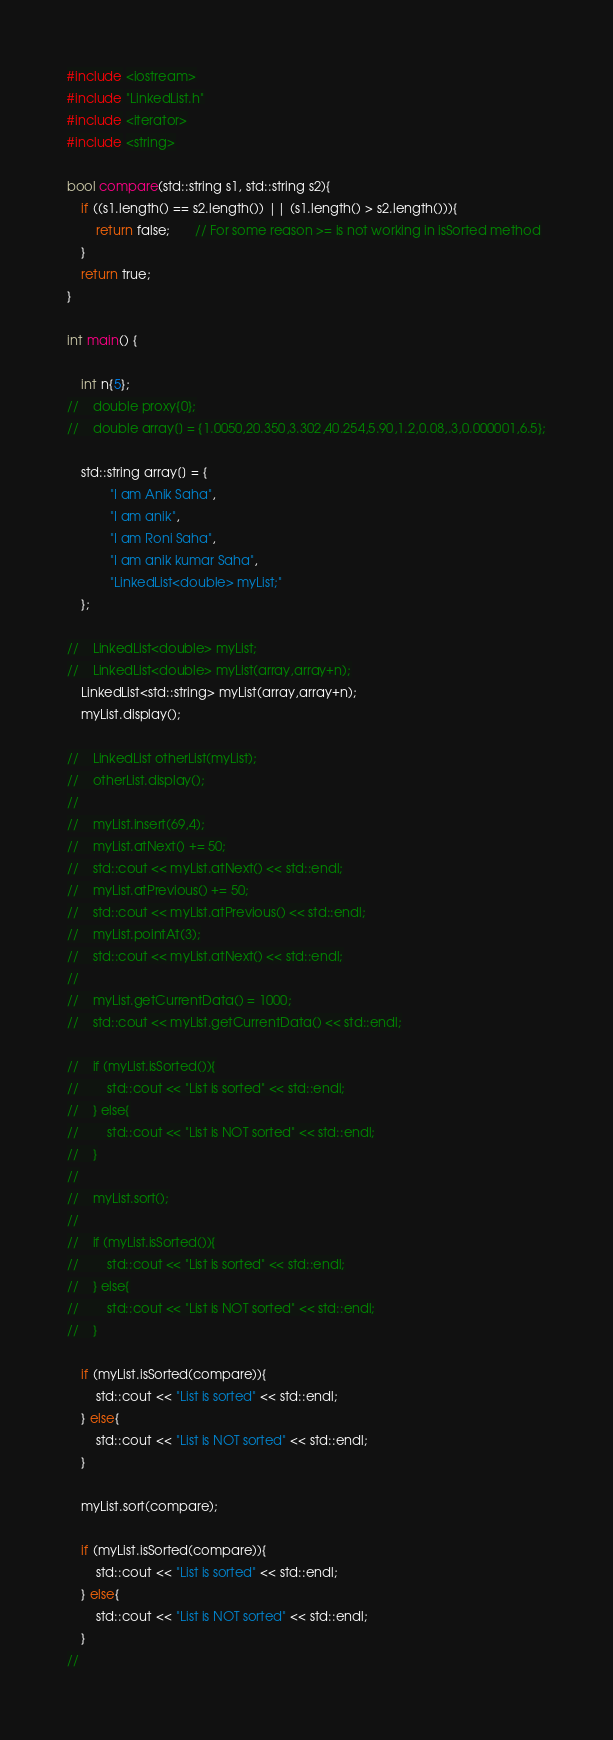Convert code to text. <code><loc_0><loc_0><loc_500><loc_500><_C++_>#include <iostream>
#include "LinkedList.h"
#include <iterator>
#include <string>

bool compare(std::string s1, std::string s2){
    if ((s1.length() == s2.length()) || (s1.length() > s2.length())){
        return false;       // For some reason >= is not working in isSorted method
    }
    return true;
}

int main() {

    int n{5};
//    double proxy{0};
//    double array[] = {1.0050,20.350,3.302,40.254,5.90,1.2,0.08,.3,0.000001,6.5};

    std::string array[] = {
            "I am Anik Saha",
            "I am anik",
            "I am Roni Saha",
            "I am anik kumar Saha",
            "LinkedList<double> myList;"
    };

//    LinkedList<double> myList;
//    LinkedList<double> myList(array,array+n);
    LinkedList<std::string> myList(array,array+n);
    myList.display();

//    LinkedList otherList(myList);
//    otherList.display();
//
//    myList.insert(69,4);
//    myList.atNext() += 50;
//    std::cout << myList.atNext() << std::endl;
//    myList.atPrevious() += 50;
//    std::cout << myList.atPrevious() << std::endl;
//    myList.pointAt(3);
//    std::cout << myList.atNext() << std::endl;
//
//    myList.getCurrentData() = 1000;
//    std::cout << myList.getCurrentData() << std::endl;

//    if (myList.isSorted()){
//        std::cout << "List is sorted" << std::endl;
//    } else{
//        std::cout << "List is NOT sorted" << std::endl;
//    }
//
//    myList.sort();
//
//    if (myList.isSorted()){
//        std::cout << "List is sorted" << std::endl;
//    } else{
//        std::cout << "List is NOT sorted" << std::endl;
//    }

    if (myList.isSorted(compare)){
        std::cout << "List is sorted" << std::endl;
    } else{
        std::cout << "List is NOT sorted" << std::endl;
    }

    myList.sort(compare);

    if (myList.isSorted(compare)){
        std::cout << "List is sorted" << std::endl;
    } else{
        std::cout << "List is NOT sorted" << std::endl;
    }
//</code> 